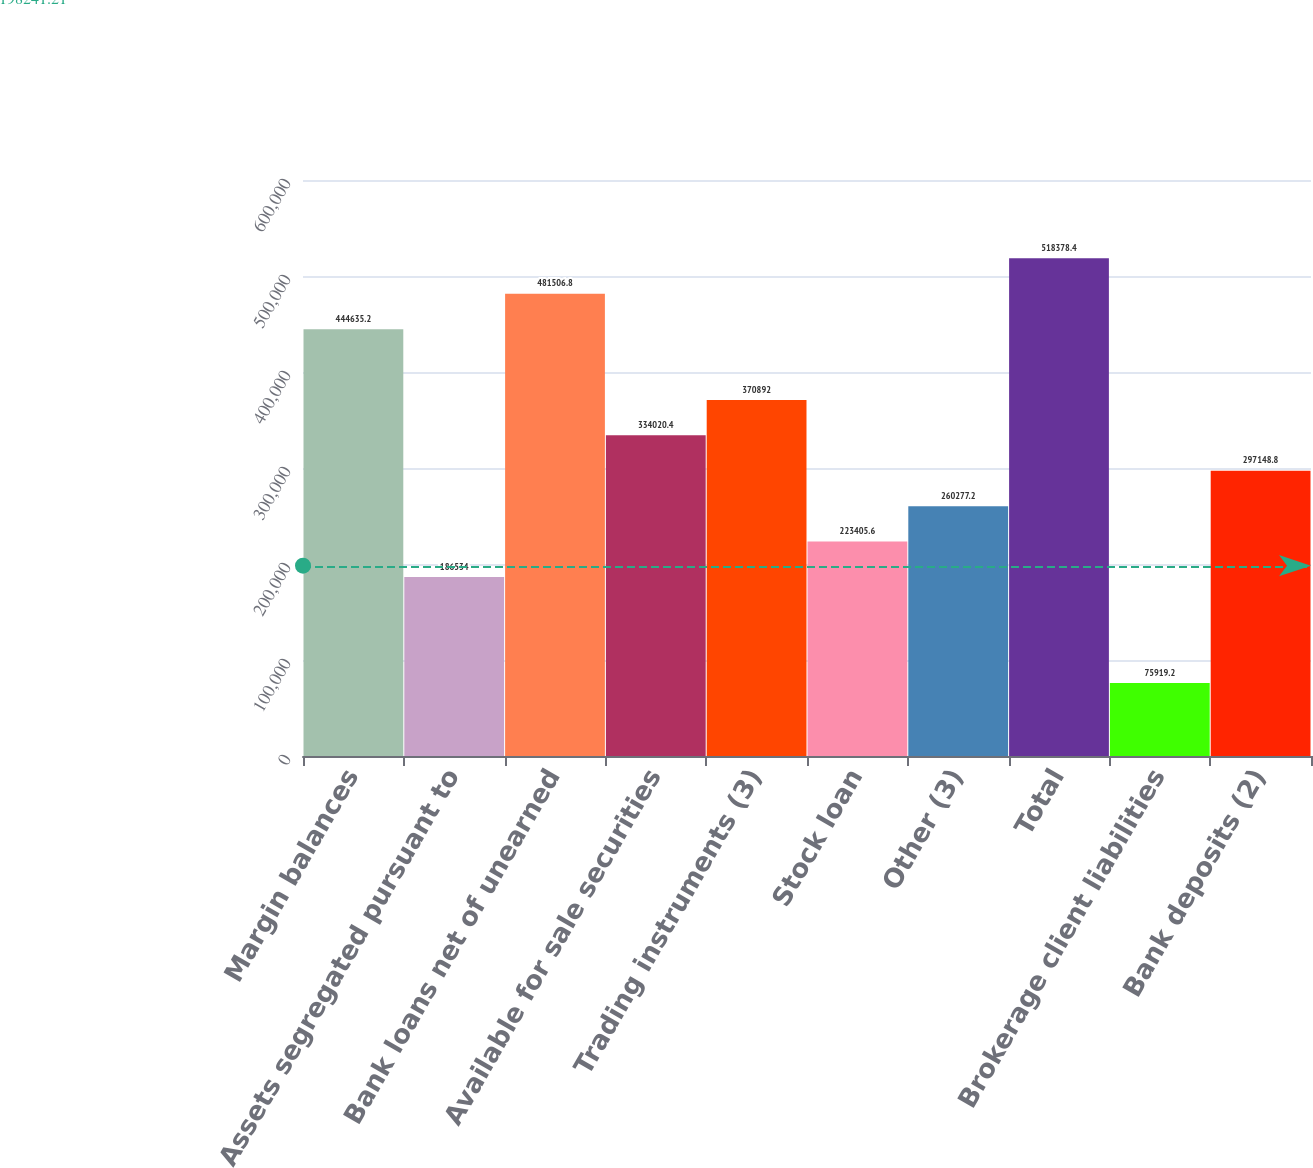Convert chart to OTSL. <chart><loc_0><loc_0><loc_500><loc_500><bar_chart><fcel>Margin balances<fcel>Assets segregated pursuant to<fcel>Bank loans net of unearned<fcel>Available for sale securities<fcel>Trading instruments (3)<fcel>Stock loan<fcel>Other (3)<fcel>Total<fcel>Brokerage client liabilities<fcel>Bank deposits (2)<nl><fcel>444635<fcel>186534<fcel>481507<fcel>334020<fcel>370892<fcel>223406<fcel>260277<fcel>518378<fcel>75919.2<fcel>297149<nl></chart> 